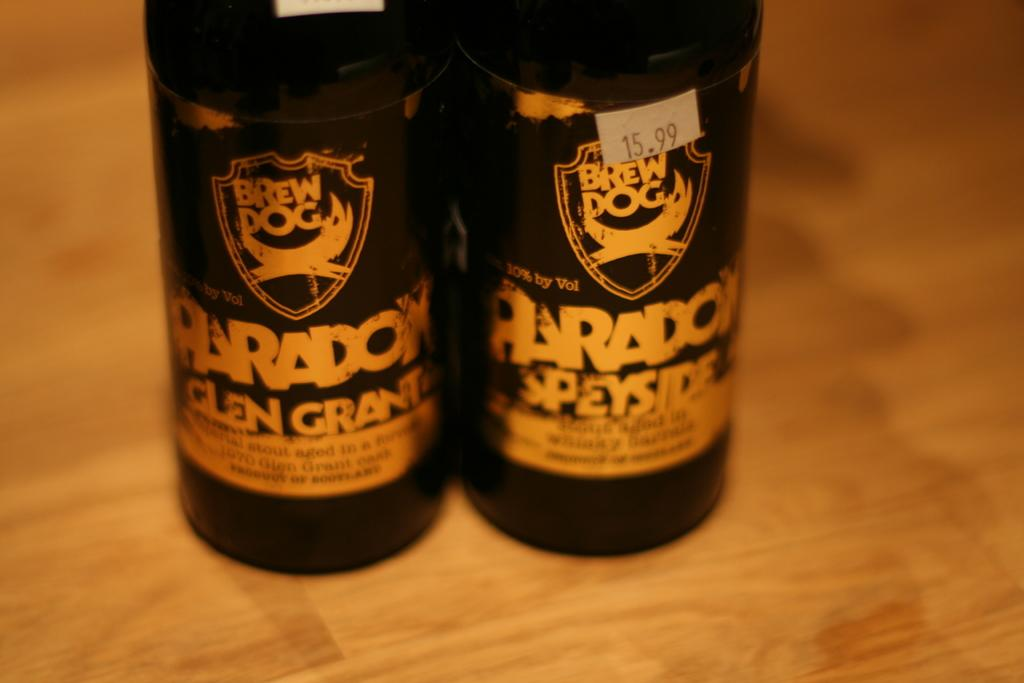<image>
Provide a brief description of the given image. A pack of beers costs $15.99 according to a small sticker. 